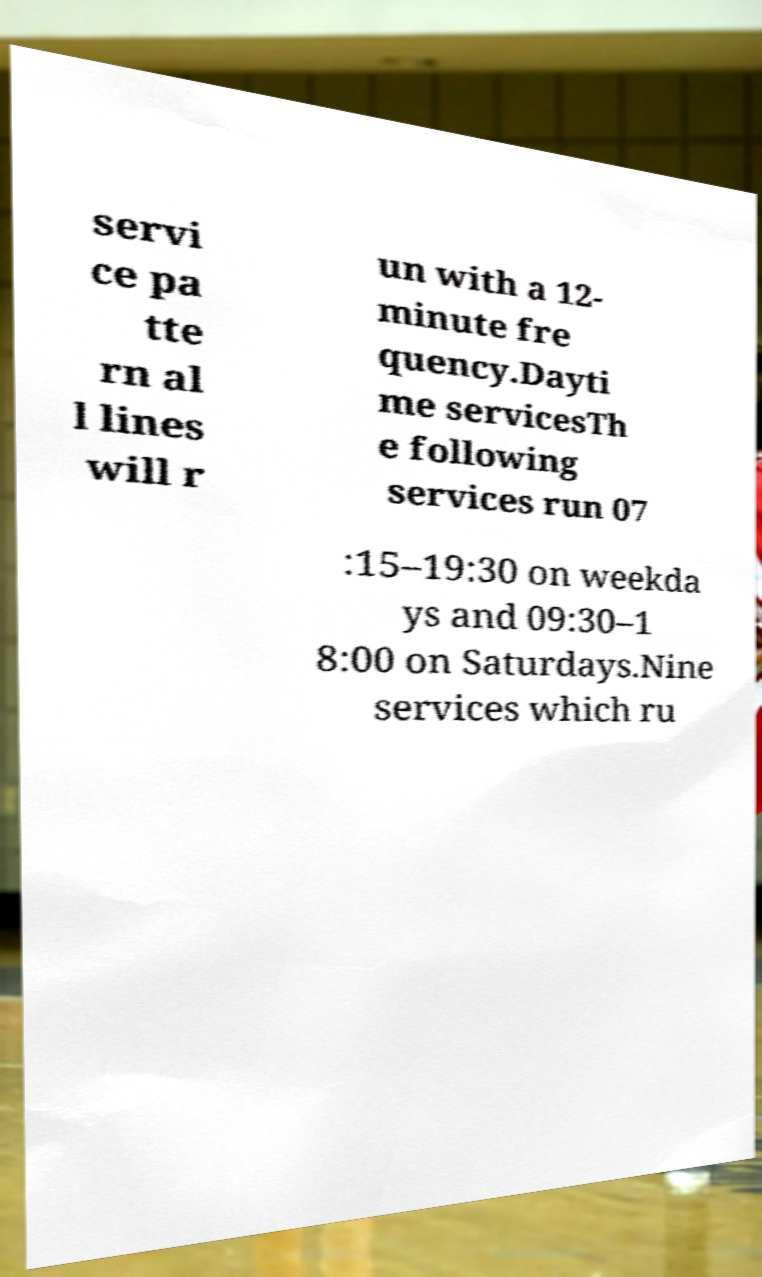Can you read and provide the text displayed in the image?This photo seems to have some interesting text. Can you extract and type it out for me? servi ce pa tte rn al l lines will r un with a 12- minute fre quency.Dayti me servicesTh e following services run 07 :15–19:30 on weekda ys and 09:30–1 8:00 on Saturdays.Nine services which ru 